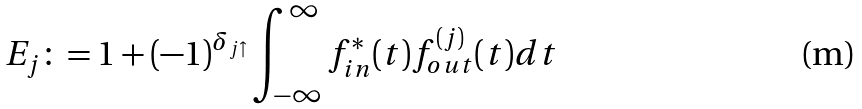Convert formula to latex. <formula><loc_0><loc_0><loc_500><loc_500>E _ { j } \colon = 1 + ( - 1 ) ^ { \delta _ { j { \uparrow } } } \int _ { - \infty } ^ { \infty } f ^ { * } _ { i n } ( t ) f ^ { ( j ) } _ { o u t } ( t ) d t</formula> 